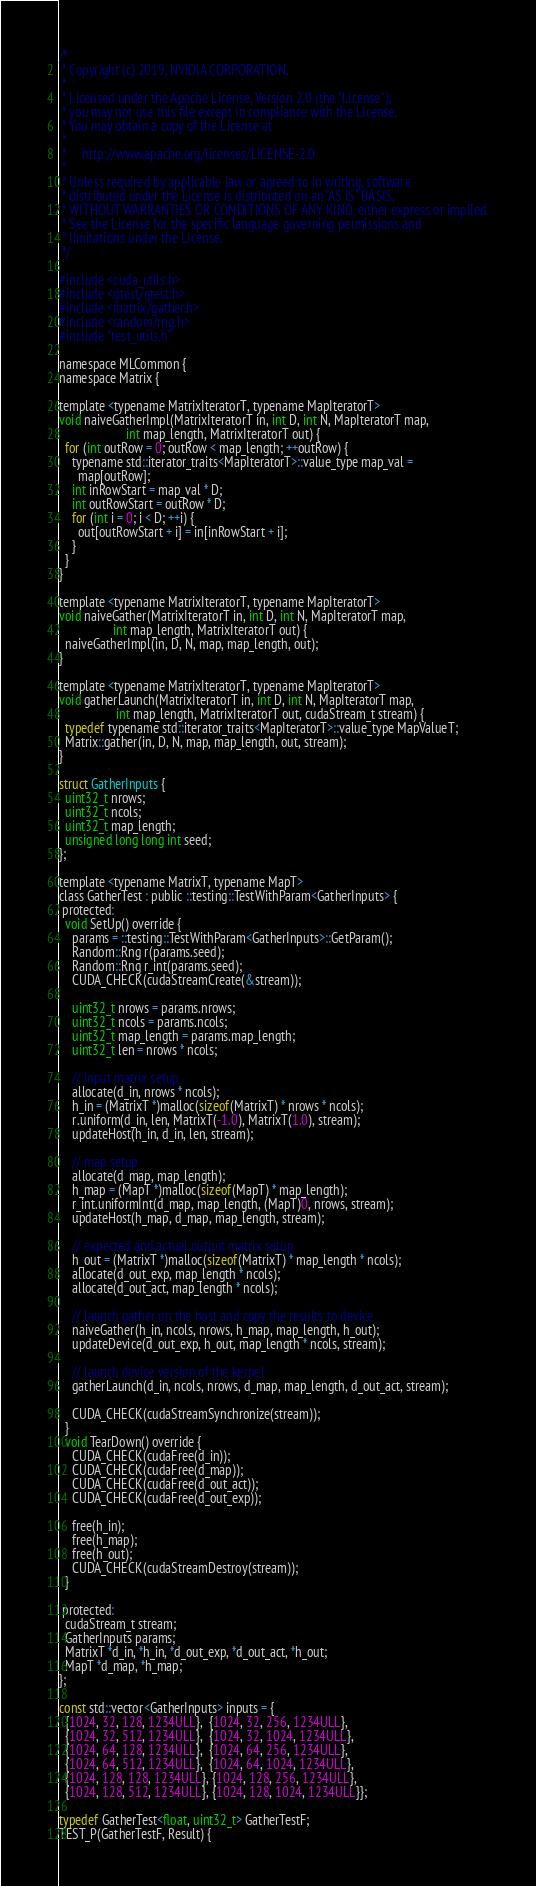Convert code to text. <code><loc_0><loc_0><loc_500><loc_500><_Cuda_>/*
 * Copyright (c) 2019, NVIDIA CORPORATION.
 *
 * Licensed under the Apache License, Version 2.0 (the "License");
 * you may not use this file except in compliance with the License.
 * You may obtain a copy of the License at
 *
 *     http://www.apache.org/licenses/LICENSE-2.0
 *
 * Unless required by applicable law or agreed to in writing, software
 * distributed under the License is distributed on an "AS IS" BASIS,
 * WITHOUT WARRANTIES OR CONDITIONS OF ANY KIND, either express or implied.
 * See the License for the specific language governing permissions and
 * limitations under the License.
 */

#include <cuda_utils.h>
#include <gtest/gtest.h>
#include <matrix/gather.h>
#include <random/rng.h>
#include "test_utils.h"

namespace MLCommon {
namespace Matrix {

template <typename MatrixIteratorT, typename MapIteratorT>
void naiveGatherImpl(MatrixIteratorT in, int D, int N, MapIteratorT map,
                     int map_length, MatrixIteratorT out) {
  for (int outRow = 0; outRow < map_length; ++outRow) {
    typename std::iterator_traits<MapIteratorT>::value_type map_val =
      map[outRow];
    int inRowStart = map_val * D;
    int outRowStart = outRow * D;
    for (int i = 0; i < D; ++i) {
      out[outRowStart + i] = in[inRowStart + i];
    }
  }
}

template <typename MatrixIteratorT, typename MapIteratorT>
void naiveGather(MatrixIteratorT in, int D, int N, MapIteratorT map,
                 int map_length, MatrixIteratorT out) {
  naiveGatherImpl(in, D, N, map, map_length, out);
}

template <typename MatrixIteratorT, typename MapIteratorT>
void gatherLaunch(MatrixIteratorT in, int D, int N, MapIteratorT map,
                  int map_length, MatrixIteratorT out, cudaStream_t stream) {
  typedef typename std::iterator_traits<MapIteratorT>::value_type MapValueT;
  Matrix::gather(in, D, N, map, map_length, out, stream);
}

struct GatherInputs {
  uint32_t nrows;
  uint32_t ncols;
  uint32_t map_length;
  unsigned long long int seed;
};

template <typename MatrixT, typename MapT>
class GatherTest : public ::testing::TestWithParam<GatherInputs> {
 protected:
  void SetUp() override {
    params = ::testing::TestWithParam<GatherInputs>::GetParam();
    Random::Rng r(params.seed);
    Random::Rng r_int(params.seed);
    CUDA_CHECK(cudaStreamCreate(&stream));

    uint32_t nrows = params.nrows;
    uint32_t ncols = params.ncols;
    uint32_t map_length = params.map_length;
    uint32_t len = nrows * ncols;

    // input matrix setup
    allocate(d_in, nrows * ncols);
    h_in = (MatrixT *)malloc(sizeof(MatrixT) * nrows * ncols);
    r.uniform(d_in, len, MatrixT(-1.0), MatrixT(1.0), stream);
    updateHost(h_in, d_in, len, stream);

    // map setup
    allocate(d_map, map_length);
    h_map = (MapT *)malloc(sizeof(MapT) * map_length);
    r_int.uniformInt(d_map, map_length, (MapT)0, nrows, stream);
    updateHost(h_map, d_map, map_length, stream);

    // expected and actual output matrix setup
    h_out = (MatrixT *)malloc(sizeof(MatrixT) * map_length * ncols);
    allocate(d_out_exp, map_length * ncols);
    allocate(d_out_act, map_length * ncols);

    // launch gather on the host and copy the results to device
    naiveGather(h_in, ncols, nrows, h_map, map_length, h_out);
    updateDevice(d_out_exp, h_out, map_length * ncols, stream);

    // launch device version of the kernel
    gatherLaunch(d_in, ncols, nrows, d_map, map_length, d_out_act, stream);

    CUDA_CHECK(cudaStreamSynchronize(stream));
  }
  void TearDown() override {
    CUDA_CHECK(cudaFree(d_in));
    CUDA_CHECK(cudaFree(d_map));
    CUDA_CHECK(cudaFree(d_out_act));
    CUDA_CHECK(cudaFree(d_out_exp));

    free(h_in);
    free(h_map);
    free(h_out);
    CUDA_CHECK(cudaStreamDestroy(stream));
  }

 protected:
  cudaStream_t stream;
  GatherInputs params;
  MatrixT *d_in, *h_in, *d_out_exp, *d_out_act, *h_out;
  MapT *d_map, *h_map;
};

const std::vector<GatherInputs> inputs = {
  {1024, 32, 128, 1234ULL},  {1024, 32, 256, 1234ULL},
  {1024, 32, 512, 1234ULL},  {1024, 32, 1024, 1234ULL},
  {1024, 64, 128, 1234ULL},  {1024, 64, 256, 1234ULL},
  {1024, 64, 512, 1234ULL},  {1024, 64, 1024, 1234ULL},
  {1024, 128, 128, 1234ULL}, {1024, 128, 256, 1234ULL},
  {1024, 128, 512, 1234ULL}, {1024, 128, 1024, 1234ULL}};

typedef GatherTest<float, uint32_t> GatherTestF;
TEST_P(GatherTestF, Result) {</code> 